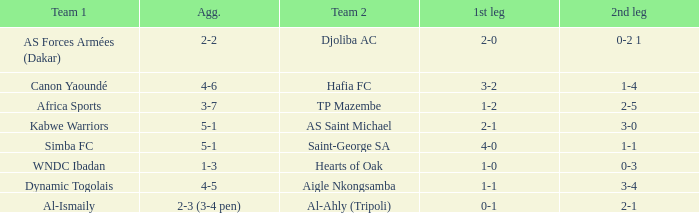When Kabwe Warriors (team 1) played, what was the result of the 1st leg? 2-1. 